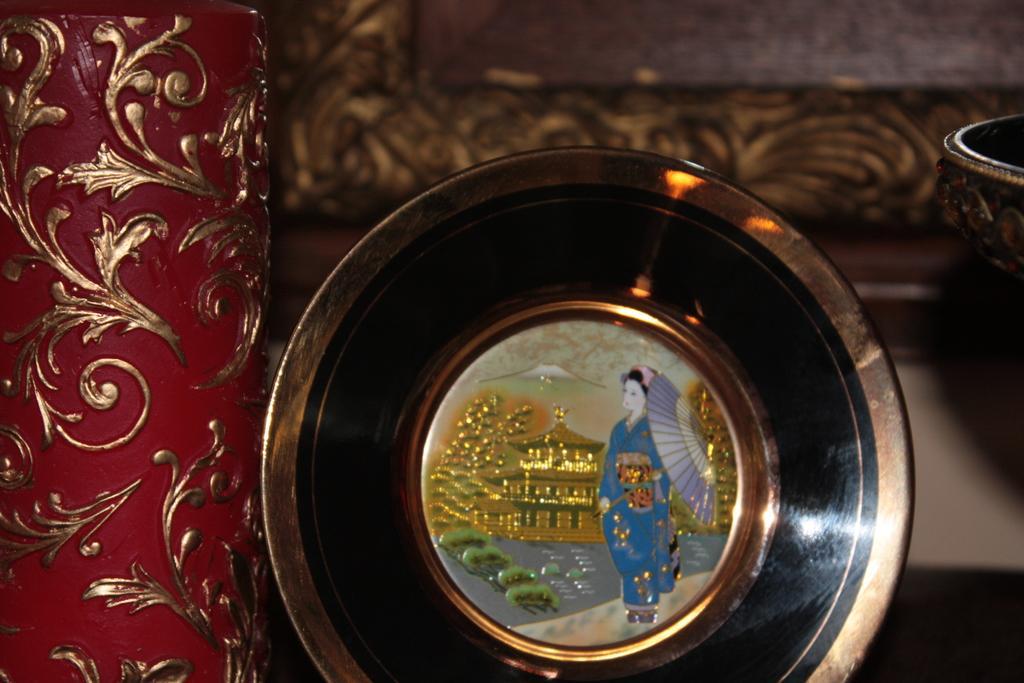Please provide a concise description of this image. This image consists of an object made up of metal. In the background, it looks like a frame. On the left, there is another object in red color. 